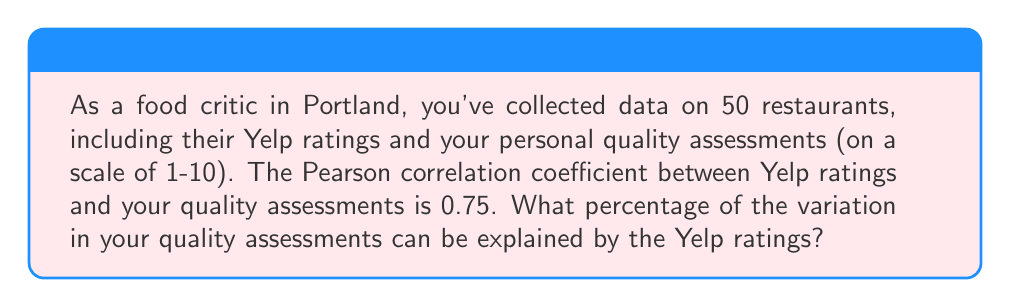Provide a solution to this math problem. To solve this problem, we need to understand the concept of the coefficient of determination, also known as R-squared. The R-squared value represents the proportion of variance in the dependent variable (in this case, your quality assessments) that is predictable from the independent variable (Yelp ratings).

The relationship between the Pearson correlation coefficient (r) and R-squared is:

$$ R^2 = r^2 $$

Where:
$R^2$ is the coefficient of determination
$r$ is the Pearson correlation coefficient

Given:
$r = 0.75$

Step 1: Calculate $R^2$
$$ R^2 = (0.75)^2 = 0.5625 $$

Step 2: Convert to percentage
To express this as a percentage, multiply by 100:

$$ 0.5625 \times 100 = 56.25\% $$

Therefore, 56.25% of the variation in your quality assessments can be explained by the Yelp ratings.
Answer: 56.25% 